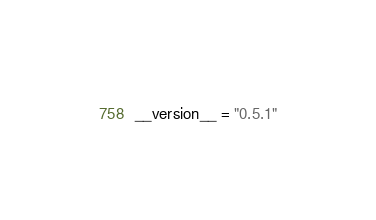<code> <loc_0><loc_0><loc_500><loc_500><_Python_>__version__ = "0.5.1"
</code> 